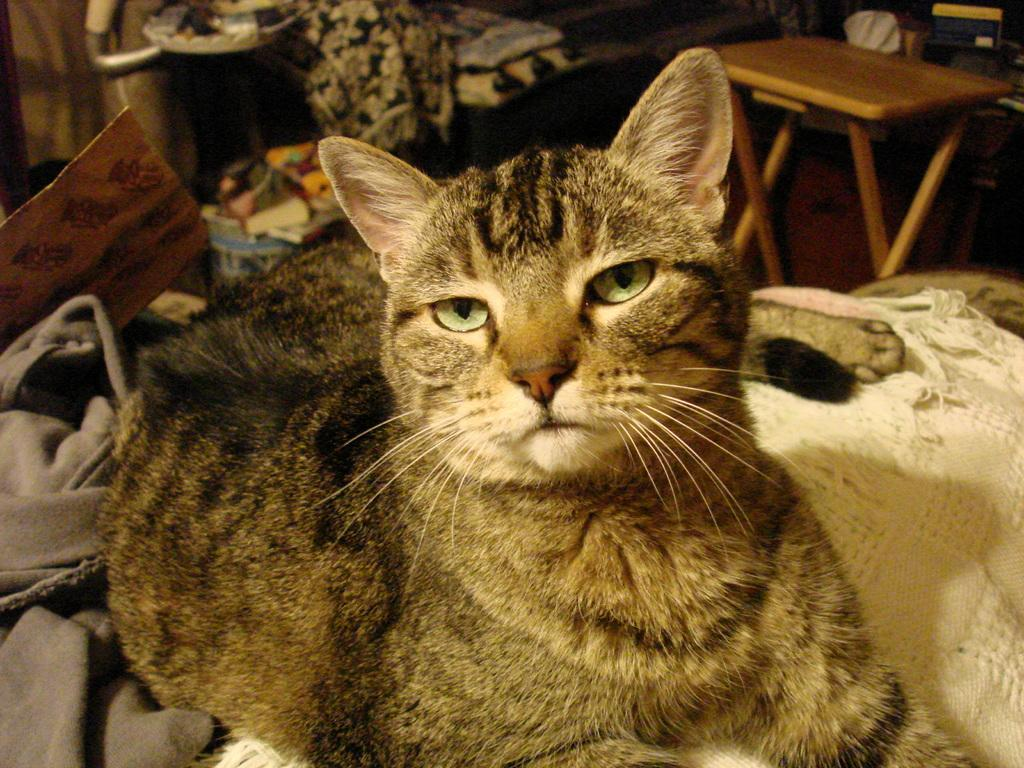What type of animal is in the image? There is a cat in the image. What is located behind the cat? There is a table behind the cat. What type of clover is the cat holding in its paw in the image? There is no clover present in the image, and the cat is not holding anything in its paw. 